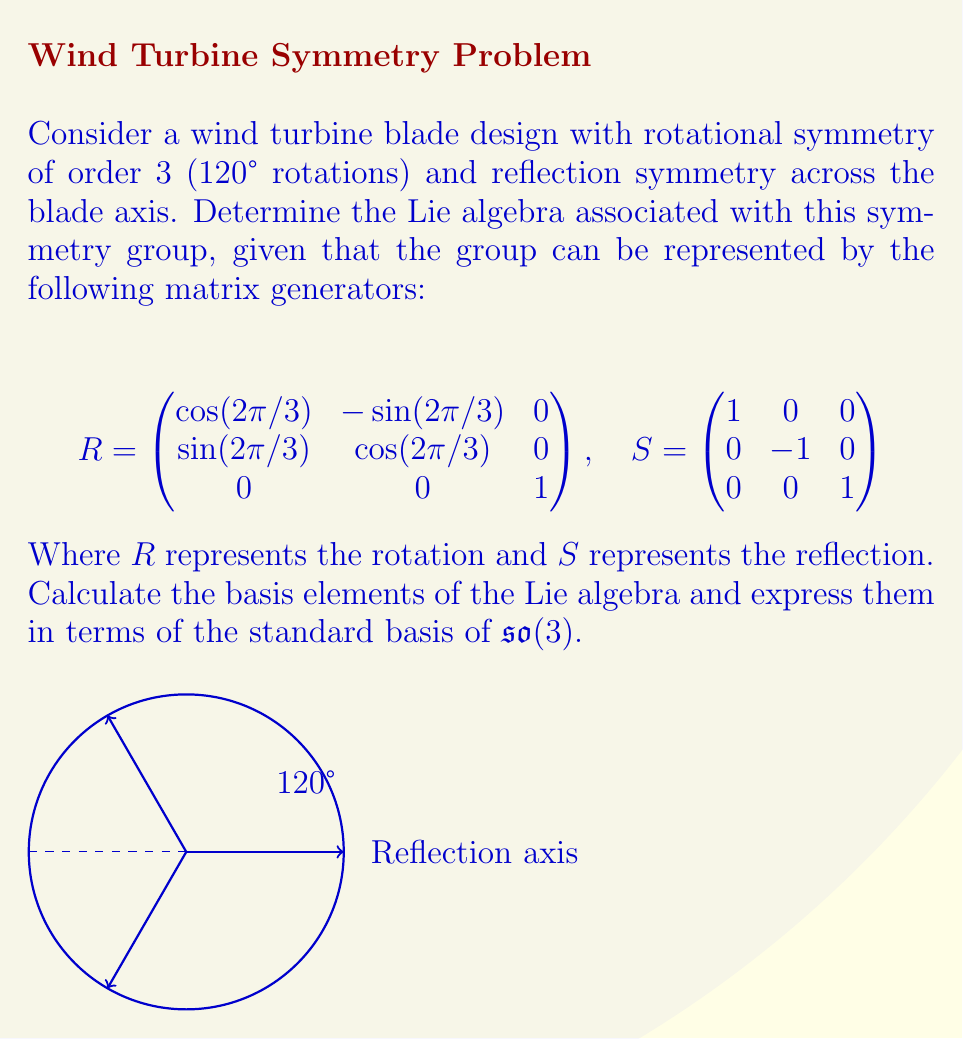Show me your answer to this math problem. To determine the Lie algebra associated with this symmetry group, we need to follow these steps:

1) First, we need to calculate the infinitesimal generators of the group. These are obtained by differentiating the matrix exponential of the group elements at $t=0$:

   $X = \frac{d}{dt}|_{t=0} \exp(tX)$

2) For the rotation $R$, we can write it as:

   $R = \exp(tJ_3)$ where $J_3 = \begin{pmatrix}
   0 & -1 & 0 \\
   1 & 0 & 0 \\
   0 & 0 & 0
   \end{pmatrix}$

3) For the reflection $S$, we can write it as:

   $S = \exp(tJ_2)$ where $J_2 = \begin{pmatrix}
   0 & 0 & 0 \\
   0 & 0 & -1 \\
   0 & 1 & 0
   \end{pmatrix}$

4) The Lie algebra is spanned by these generators: $\{J_2, J_3\}$

5) We can express these in terms of the standard basis of $\mathfrak{so}(3)$:

   $J_1 = \begin{pmatrix}
   0 & 0 & 0 \\
   0 & 0 & -1 \\
   0 & 1 & 0
   \end{pmatrix}$,
   $J_2 = \begin{pmatrix}
   0 & 0 & 1 \\
   0 & 0 & 0 \\
   -1 & 0 & 0
   \end{pmatrix}$,
   $J_3 = \begin{pmatrix}
   0 & -1 & 0 \\
   1 & 0 & 0 \\
   0 & 0 & 0
   \end{pmatrix}$

6) Our Lie algebra is therefore $\text{span}\{J_2, J_3\}$, which is a 2-dimensional subalgebra of $\mathfrak{so}(3)$.
Answer: $\text{span}\{J_2, J_3\} \subset \mathfrak{so}(3)$ 